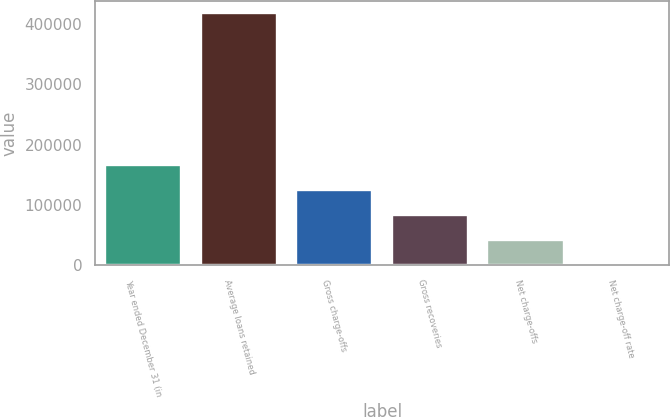Convert chart to OTSL. <chart><loc_0><loc_0><loc_500><loc_500><bar_chart><fcel>Year ended December 31 (in<fcel>Average loans retained<fcel>Gross charge-offs<fcel>Gross recoveries<fcel>Net charge-offs<fcel>Net charge-off rate<nl><fcel>166731<fcel>416828<fcel>125048<fcel>83365.6<fcel>41682.8<fcel>0.04<nl></chart> 